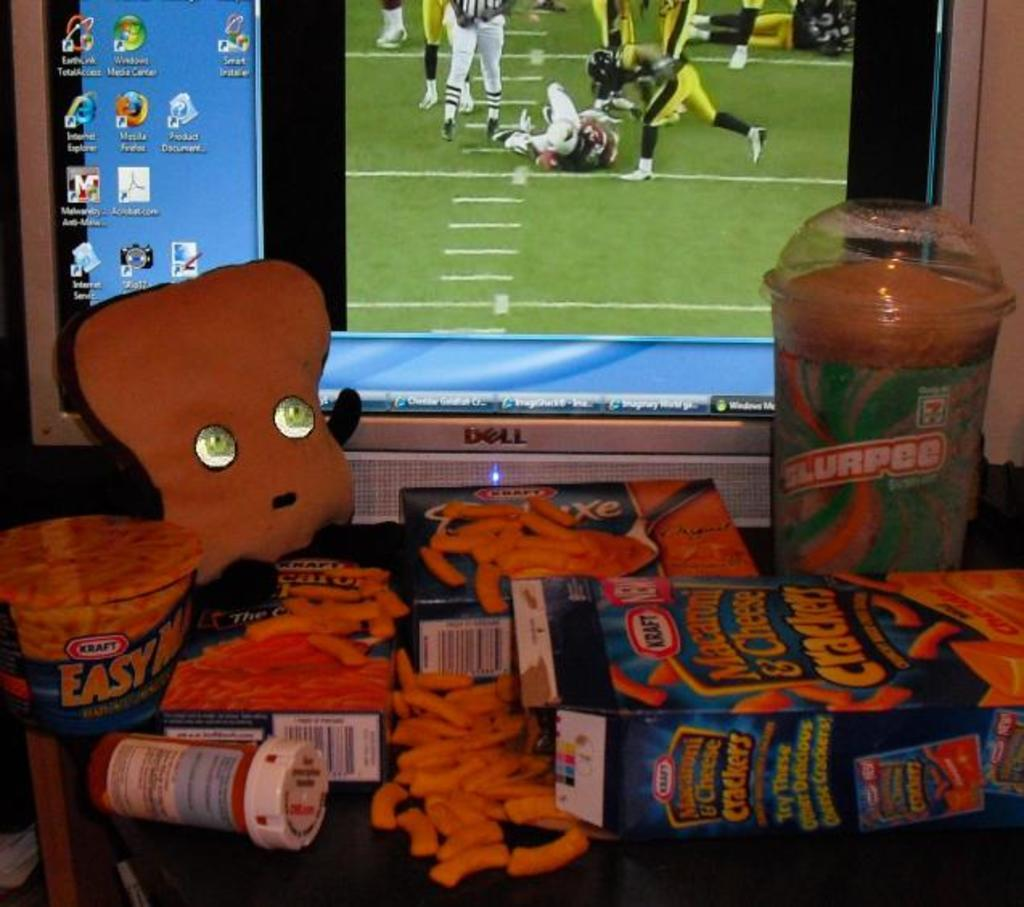<image>
Create a compact narrative representing the image presented. The monitor that is in the picture is a Dell monitor 